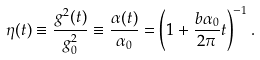<formula> <loc_0><loc_0><loc_500><loc_500>\eta ( t ) \equiv \frac { g ^ { 2 } ( t ) } { g ^ { 2 } _ { 0 } } \equiv \frac { \alpha ( t ) } { \alpha _ { 0 } } = \left ( 1 + { \frac { b \alpha _ { 0 } } { 2 \pi } } t \right ) ^ { - 1 } .</formula> 